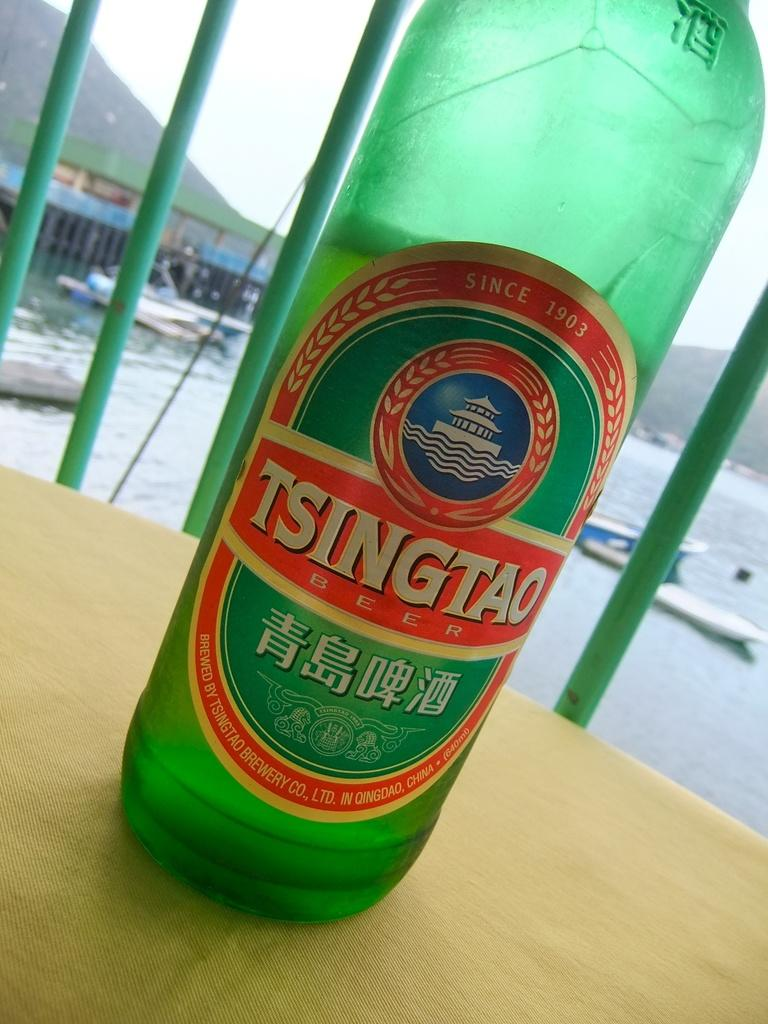Provide a one-sentence caption for the provided image. Tsingtao bottle in front of a background with water and ships. 